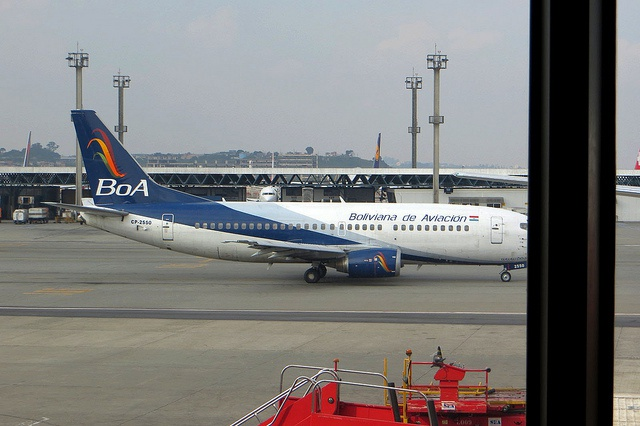Describe the objects in this image and their specific colors. I can see airplane in darkgray, lightgray, darkblue, and gray tones and airplane in darkgray, lightgray, and gray tones in this image. 